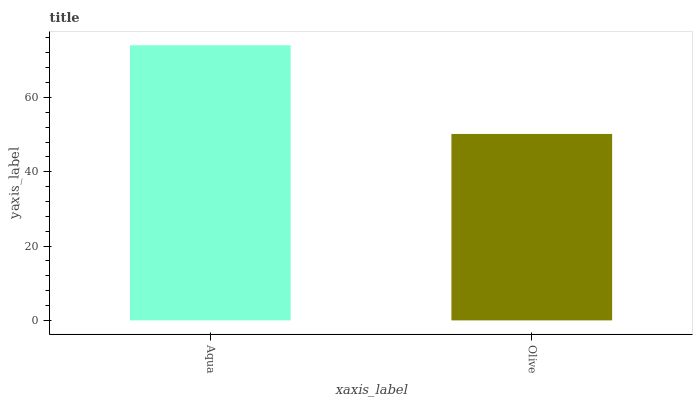Is Olive the minimum?
Answer yes or no. Yes. Is Aqua the maximum?
Answer yes or no. Yes. Is Olive the maximum?
Answer yes or no. No. Is Aqua greater than Olive?
Answer yes or no. Yes. Is Olive less than Aqua?
Answer yes or no. Yes. Is Olive greater than Aqua?
Answer yes or no. No. Is Aqua less than Olive?
Answer yes or no. No. Is Aqua the high median?
Answer yes or no. Yes. Is Olive the low median?
Answer yes or no. Yes. Is Olive the high median?
Answer yes or no. No. Is Aqua the low median?
Answer yes or no. No. 